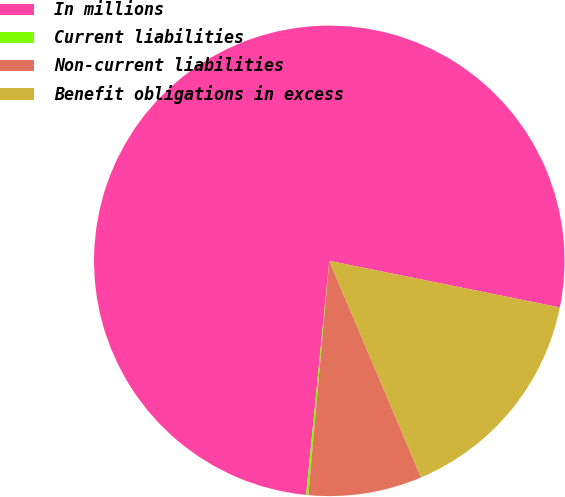Convert chart. <chart><loc_0><loc_0><loc_500><loc_500><pie_chart><fcel>In millions<fcel>Current liabilities<fcel>Non-current liabilities<fcel>Benefit obligations in excess<nl><fcel>76.61%<fcel>0.15%<fcel>7.8%<fcel>15.44%<nl></chart> 